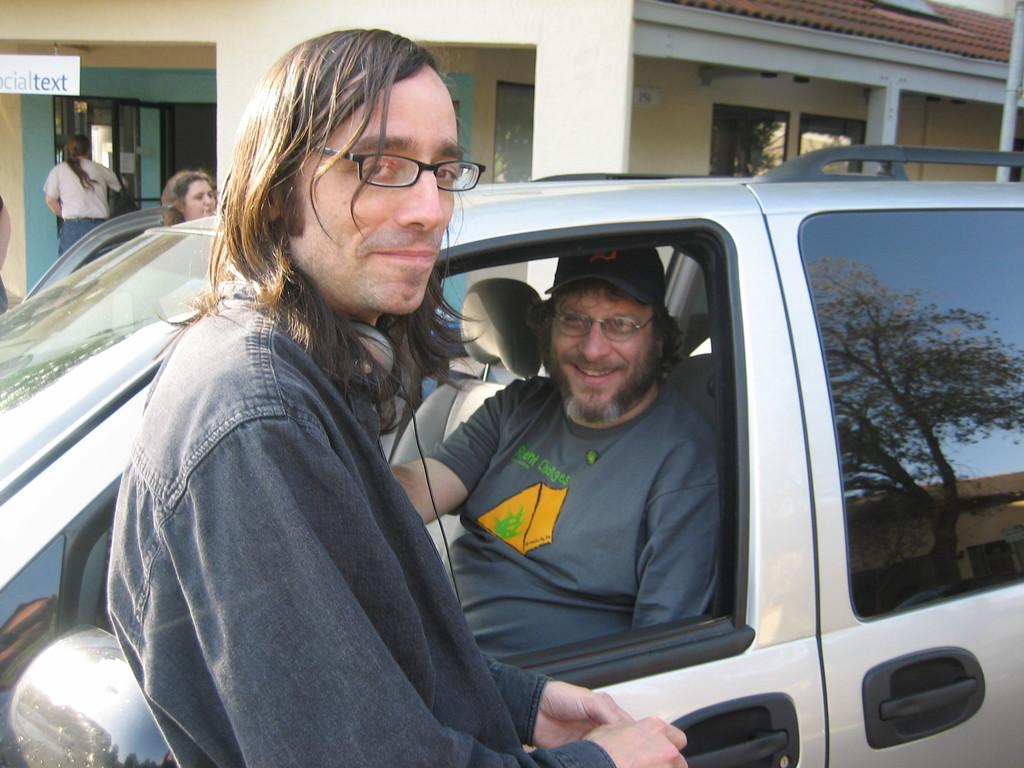What are the people in the image doing? There are persons standing in the image. Can you describe the person inside the car? There is a person sitting inside a car. What can be seen in the background of the image? There is a house visible in the background of the image. What type of bird is the owner trading with the person inside the car? There is no bird or trade present in the image; it only features persons standing and a person sitting inside a car with a house in the background. 